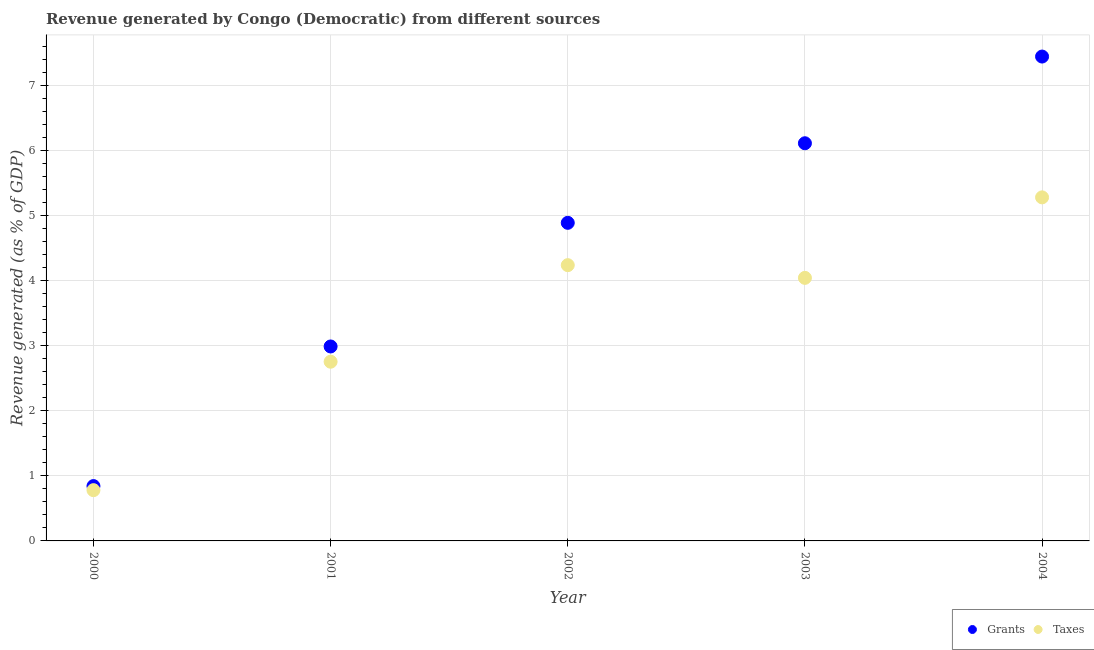What is the revenue generated by grants in 2000?
Provide a succinct answer. 0.84. Across all years, what is the maximum revenue generated by taxes?
Ensure brevity in your answer.  5.28. Across all years, what is the minimum revenue generated by taxes?
Offer a terse response. 0.78. What is the total revenue generated by grants in the graph?
Ensure brevity in your answer.  22.26. What is the difference between the revenue generated by grants in 2000 and that in 2003?
Offer a very short reply. -5.27. What is the difference between the revenue generated by grants in 2001 and the revenue generated by taxes in 2000?
Your response must be concise. 2.21. What is the average revenue generated by taxes per year?
Give a very brief answer. 3.42. In the year 2002, what is the difference between the revenue generated by taxes and revenue generated by grants?
Your answer should be very brief. -0.65. What is the ratio of the revenue generated by grants in 2001 to that in 2004?
Offer a very short reply. 0.4. What is the difference between the highest and the second highest revenue generated by taxes?
Your answer should be very brief. 1.04. What is the difference between the highest and the lowest revenue generated by grants?
Give a very brief answer. 6.6. Is the revenue generated by taxes strictly greater than the revenue generated by grants over the years?
Offer a terse response. No. Is the revenue generated by grants strictly less than the revenue generated by taxes over the years?
Your response must be concise. No. How many dotlines are there?
Provide a short and direct response. 2. How many years are there in the graph?
Offer a very short reply. 5. What is the difference between two consecutive major ticks on the Y-axis?
Your response must be concise. 1. Are the values on the major ticks of Y-axis written in scientific E-notation?
Ensure brevity in your answer.  No. Does the graph contain any zero values?
Keep it short and to the point. No. Does the graph contain grids?
Ensure brevity in your answer.  Yes. Where does the legend appear in the graph?
Provide a succinct answer. Bottom right. What is the title of the graph?
Your answer should be compact. Revenue generated by Congo (Democratic) from different sources. What is the label or title of the Y-axis?
Your answer should be very brief. Revenue generated (as % of GDP). What is the Revenue generated (as % of GDP) of Grants in 2000?
Your response must be concise. 0.84. What is the Revenue generated (as % of GDP) of Taxes in 2000?
Give a very brief answer. 0.78. What is the Revenue generated (as % of GDP) in Grants in 2001?
Keep it short and to the point. 2.99. What is the Revenue generated (as % of GDP) in Taxes in 2001?
Your answer should be very brief. 2.75. What is the Revenue generated (as % of GDP) in Grants in 2002?
Your answer should be very brief. 4.89. What is the Revenue generated (as % of GDP) of Taxes in 2002?
Your answer should be compact. 4.24. What is the Revenue generated (as % of GDP) in Grants in 2003?
Your answer should be very brief. 6.11. What is the Revenue generated (as % of GDP) of Taxes in 2003?
Make the answer very short. 4.04. What is the Revenue generated (as % of GDP) of Grants in 2004?
Provide a succinct answer. 7.44. What is the Revenue generated (as % of GDP) of Taxes in 2004?
Give a very brief answer. 5.28. Across all years, what is the maximum Revenue generated (as % of GDP) of Grants?
Keep it short and to the point. 7.44. Across all years, what is the maximum Revenue generated (as % of GDP) of Taxes?
Provide a short and direct response. 5.28. Across all years, what is the minimum Revenue generated (as % of GDP) of Grants?
Give a very brief answer. 0.84. Across all years, what is the minimum Revenue generated (as % of GDP) in Taxes?
Keep it short and to the point. 0.78. What is the total Revenue generated (as % of GDP) in Grants in the graph?
Give a very brief answer. 22.26. What is the total Revenue generated (as % of GDP) in Taxes in the graph?
Ensure brevity in your answer.  17.08. What is the difference between the Revenue generated (as % of GDP) of Grants in 2000 and that in 2001?
Keep it short and to the point. -2.14. What is the difference between the Revenue generated (as % of GDP) in Taxes in 2000 and that in 2001?
Your answer should be compact. -1.97. What is the difference between the Revenue generated (as % of GDP) of Grants in 2000 and that in 2002?
Your answer should be very brief. -4.04. What is the difference between the Revenue generated (as % of GDP) of Taxes in 2000 and that in 2002?
Give a very brief answer. -3.46. What is the difference between the Revenue generated (as % of GDP) in Grants in 2000 and that in 2003?
Your answer should be compact. -5.27. What is the difference between the Revenue generated (as % of GDP) in Taxes in 2000 and that in 2003?
Make the answer very short. -3.26. What is the difference between the Revenue generated (as % of GDP) of Grants in 2000 and that in 2004?
Give a very brief answer. -6.6. What is the difference between the Revenue generated (as % of GDP) in Taxes in 2000 and that in 2004?
Provide a succinct answer. -4.5. What is the difference between the Revenue generated (as % of GDP) in Grants in 2001 and that in 2002?
Your response must be concise. -1.9. What is the difference between the Revenue generated (as % of GDP) of Taxes in 2001 and that in 2002?
Offer a terse response. -1.48. What is the difference between the Revenue generated (as % of GDP) of Grants in 2001 and that in 2003?
Give a very brief answer. -3.12. What is the difference between the Revenue generated (as % of GDP) of Taxes in 2001 and that in 2003?
Your response must be concise. -1.29. What is the difference between the Revenue generated (as % of GDP) of Grants in 2001 and that in 2004?
Offer a very short reply. -4.45. What is the difference between the Revenue generated (as % of GDP) of Taxes in 2001 and that in 2004?
Give a very brief answer. -2.52. What is the difference between the Revenue generated (as % of GDP) in Grants in 2002 and that in 2003?
Your answer should be compact. -1.22. What is the difference between the Revenue generated (as % of GDP) in Taxes in 2002 and that in 2003?
Keep it short and to the point. 0.2. What is the difference between the Revenue generated (as % of GDP) of Grants in 2002 and that in 2004?
Ensure brevity in your answer.  -2.55. What is the difference between the Revenue generated (as % of GDP) in Taxes in 2002 and that in 2004?
Offer a terse response. -1.04. What is the difference between the Revenue generated (as % of GDP) of Grants in 2003 and that in 2004?
Offer a very short reply. -1.33. What is the difference between the Revenue generated (as % of GDP) of Taxes in 2003 and that in 2004?
Provide a short and direct response. -1.24. What is the difference between the Revenue generated (as % of GDP) of Grants in 2000 and the Revenue generated (as % of GDP) of Taxes in 2001?
Your answer should be very brief. -1.91. What is the difference between the Revenue generated (as % of GDP) of Grants in 2000 and the Revenue generated (as % of GDP) of Taxes in 2002?
Ensure brevity in your answer.  -3.39. What is the difference between the Revenue generated (as % of GDP) of Grants in 2000 and the Revenue generated (as % of GDP) of Taxes in 2003?
Keep it short and to the point. -3.2. What is the difference between the Revenue generated (as % of GDP) in Grants in 2000 and the Revenue generated (as % of GDP) in Taxes in 2004?
Provide a succinct answer. -4.43. What is the difference between the Revenue generated (as % of GDP) of Grants in 2001 and the Revenue generated (as % of GDP) of Taxes in 2002?
Keep it short and to the point. -1.25. What is the difference between the Revenue generated (as % of GDP) of Grants in 2001 and the Revenue generated (as % of GDP) of Taxes in 2003?
Provide a short and direct response. -1.05. What is the difference between the Revenue generated (as % of GDP) in Grants in 2001 and the Revenue generated (as % of GDP) in Taxes in 2004?
Your response must be concise. -2.29. What is the difference between the Revenue generated (as % of GDP) in Grants in 2002 and the Revenue generated (as % of GDP) in Taxes in 2003?
Your answer should be very brief. 0.85. What is the difference between the Revenue generated (as % of GDP) in Grants in 2002 and the Revenue generated (as % of GDP) in Taxes in 2004?
Your answer should be very brief. -0.39. What is the difference between the Revenue generated (as % of GDP) of Grants in 2003 and the Revenue generated (as % of GDP) of Taxes in 2004?
Ensure brevity in your answer.  0.83. What is the average Revenue generated (as % of GDP) of Grants per year?
Your answer should be very brief. 4.45. What is the average Revenue generated (as % of GDP) in Taxes per year?
Provide a succinct answer. 3.42. In the year 2000, what is the difference between the Revenue generated (as % of GDP) in Grants and Revenue generated (as % of GDP) in Taxes?
Your answer should be compact. 0.06. In the year 2001, what is the difference between the Revenue generated (as % of GDP) of Grants and Revenue generated (as % of GDP) of Taxes?
Your answer should be very brief. 0.23. In the year 2002, what is the difference between the Revenue generated (as % of GDP) in Grants and Revenue generated (as % of GDP) in Taxes?
Offer a terse response. 0.65. In the year 2003, what is the difference between the Revenue generated (as % of GDP) in Grants and Revenue generated (as % of GDP) in Taxes?
Provide a short and direct response. 2.07. In the year 2004, what is the difference between the Revenue generated (as % of GDP) of Grants and Revenue generated (as % of GDP) of Taxes?
Your answer should be compact. 2.16. What is the ratio of the Revenue generated (as % of GDP) in Grants in 2000 to that in 2001?
Keep it short and to the point. 0.28. What is the ratio of the Revenue generated (as % of GDP) of Taxes in 2000 to that in 2001?
Keep it short and to the point. 0.28. What is the ratio of the Revenue generated (as % of GDP) in Grants in 2000 to that in 2002?
Keep it short and to the point. 0.17. What is the ratio of the Revenue generated (as % of GDP) in Taxes in 2000 to that in 2002?
Your answer should be very brief. 0.18. What is the ratio of the Revenue generated (as % of GDP) of Grants in 2000 to that in 2003?
Provide a succinct answer. 0.14. What is the ratio of the Revenue generated (as % of GDP) of Taxes in 2000 to that in 2003?
Give a very brief answer. 0.19. What is the ratio of the Revenue generated (as % of GDP) in Grants in 2000 to that in 2004?
Ensure brevity in your answer.  0.11. What is the ratio of the Revenue generated (as % of GDP) in Taxes in 2000 to that in 2004?
Provide a succinct answer. 0.15. What is the ratio of the Revenue generated (as % of GDP) of Grants in 2001 to that in 2002?
Your response must be concise. 0.61. What is the ratio of the Revenue generated (as % of GDP) in Taxes in 2001 to that in 2002?
Provide a succinct answer. 0.65. What is the ratio of the Revenue generated (as % of GDP) in Grants in 2001 to that in 2003?
Make the answer very short. 0.49. What is the ratio of the Revenue generated (as % of GDP) of Taxes in 2001 to that in 2003?
Offer a very short reply. 0.68. What is the ratio of the Revenue generated (as % of GDP) in Grants in 2001 to that in 2004?
Offer a terse response. 0.4. What is the ratio of the Revenue generated (as % of GDP) in Taxes in 2001 to that in 2004?
Offer a terse response. 0.52. What is the ratio of the Revenue generated (as % of GDP) in Grants in 2002 to that in 2003?
Provide a succinct answer. 0.8. What is the ratio of the Revenue generated (as % of GDP) of Taxes in 2002 to that in 2003?
Offer a very short reply. 1.05. What is the ratio of the Revenue generated (as % of GDP) in Grants in 2002 to that in 2004?
Make the answer very short. 0.66. What is the ratio of the Revenue generated (as % of GDP) of Taxes in 2002 to that in 2004?
Give a very brief answer. 0.8. What is the ratio of the Revenue generated (as % of GDP) in Grants in 2003 to that in 2004?
Provide a short and direct response. 0.82. What is the ratio of the Revenue generated (as % of GDP) in Taxes in 2003 to that in 2004?
Offer a terse response. 0.77. What is the difference between the highest and the second highest Revenue generated (as % of GDP) in Grants?
Keep it short and to the point. 1.33. What is the difference between the highest and the second highest Revenue generated (as % of GDP) of Taxes?
Offer a terse response. 1.04. What is the difference between the highest and the lowest Revenue generated (as % of GDP) in Grants?
Your answer should be compact. 6.6. What is the difference between the highest and the lowest Revenue generated (as % of GDP) in Taxes?
Your answer should be very brief. 4.5. 